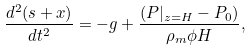Convert formula to latex. <formula><loc_0><loc_0><loc_500><loc_500>\frac { d ^ { 2 } ( s + x ) } { d t ^ { 2 } } = - g + \frac { ( P | _ { z = H } - P _ { 0 } ) } { \rho _ { m } \phi H } ,</formula> 